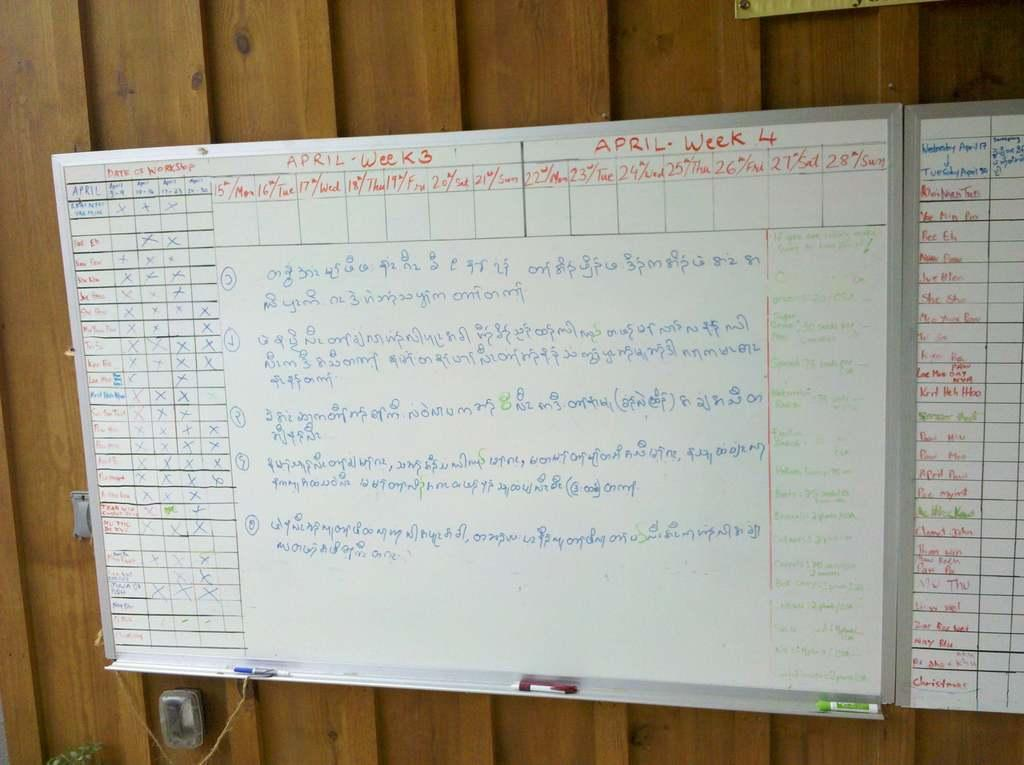<image>
Render a clear and concise summary of the photo. the word week that is on a white board 